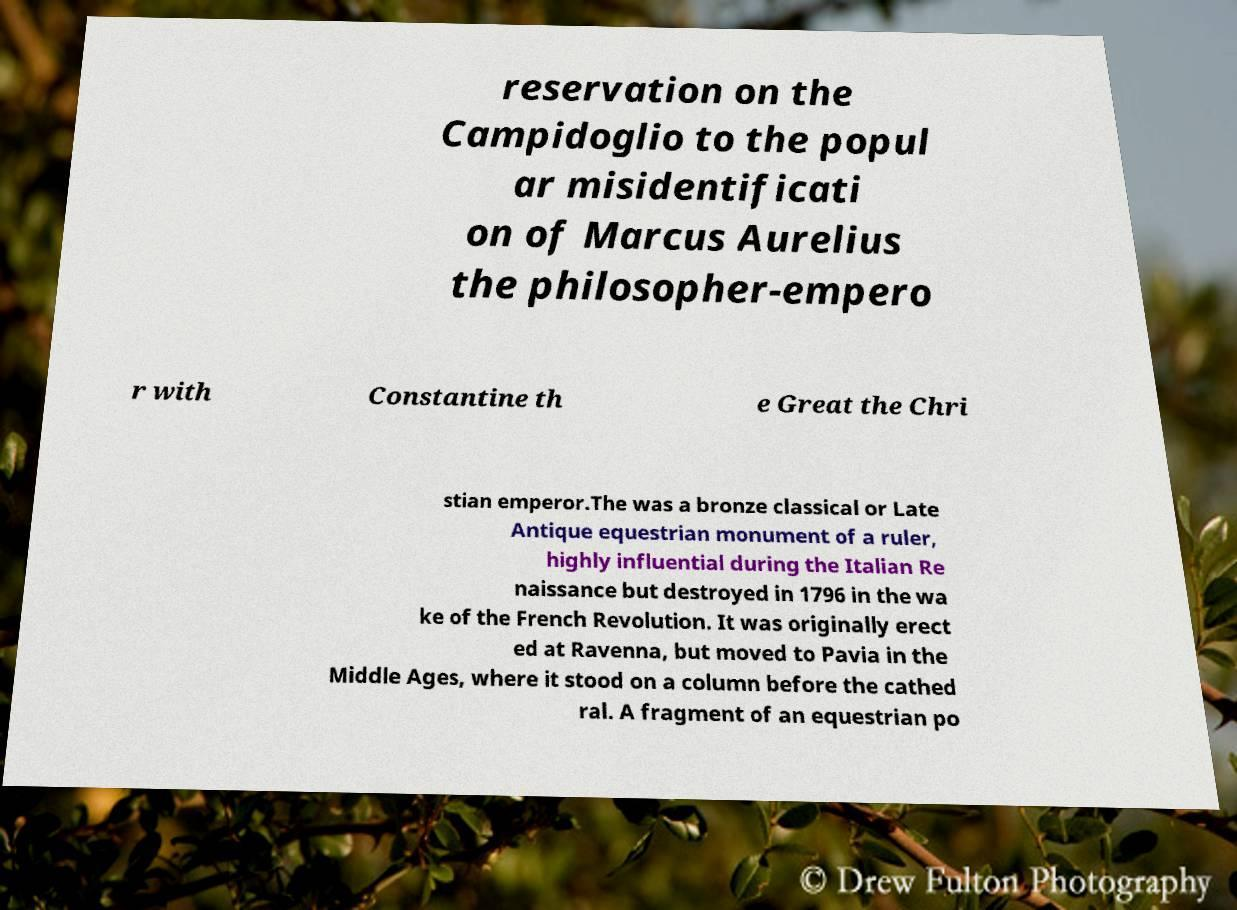Could you extract and type out the text from this image? reservation on the Campidoglio to the popul ar misidentificati on of Marcus Aurelius the philosopher-empero r with Constantine th e Great the Chri stian emperor.The was a bronze classical or Late Antique equestrian monument of a ruler, highly influential during the Italian Re naissance but destroyed in 1796 in the wa ke of the French Revolution. It was originally erect ed at Ravenna, but moved to Pavia in the Middle Ages, where it stood on a column before the cathed ral. A fragment of an equestrian po 